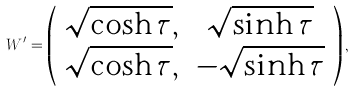<formula> <loc_0><loc_0><loc_500><loc_500>W ^ { \prime } = \left ( \begin{array} { c c } \sqrt { \cosh { \tau } } , & \sqrt { \sinh { \tau } } \\ \sqrt { \cosh { \tau } } , & - \sqrt { \sinh { \tau } } \end{array} \right ) ,</formula> 